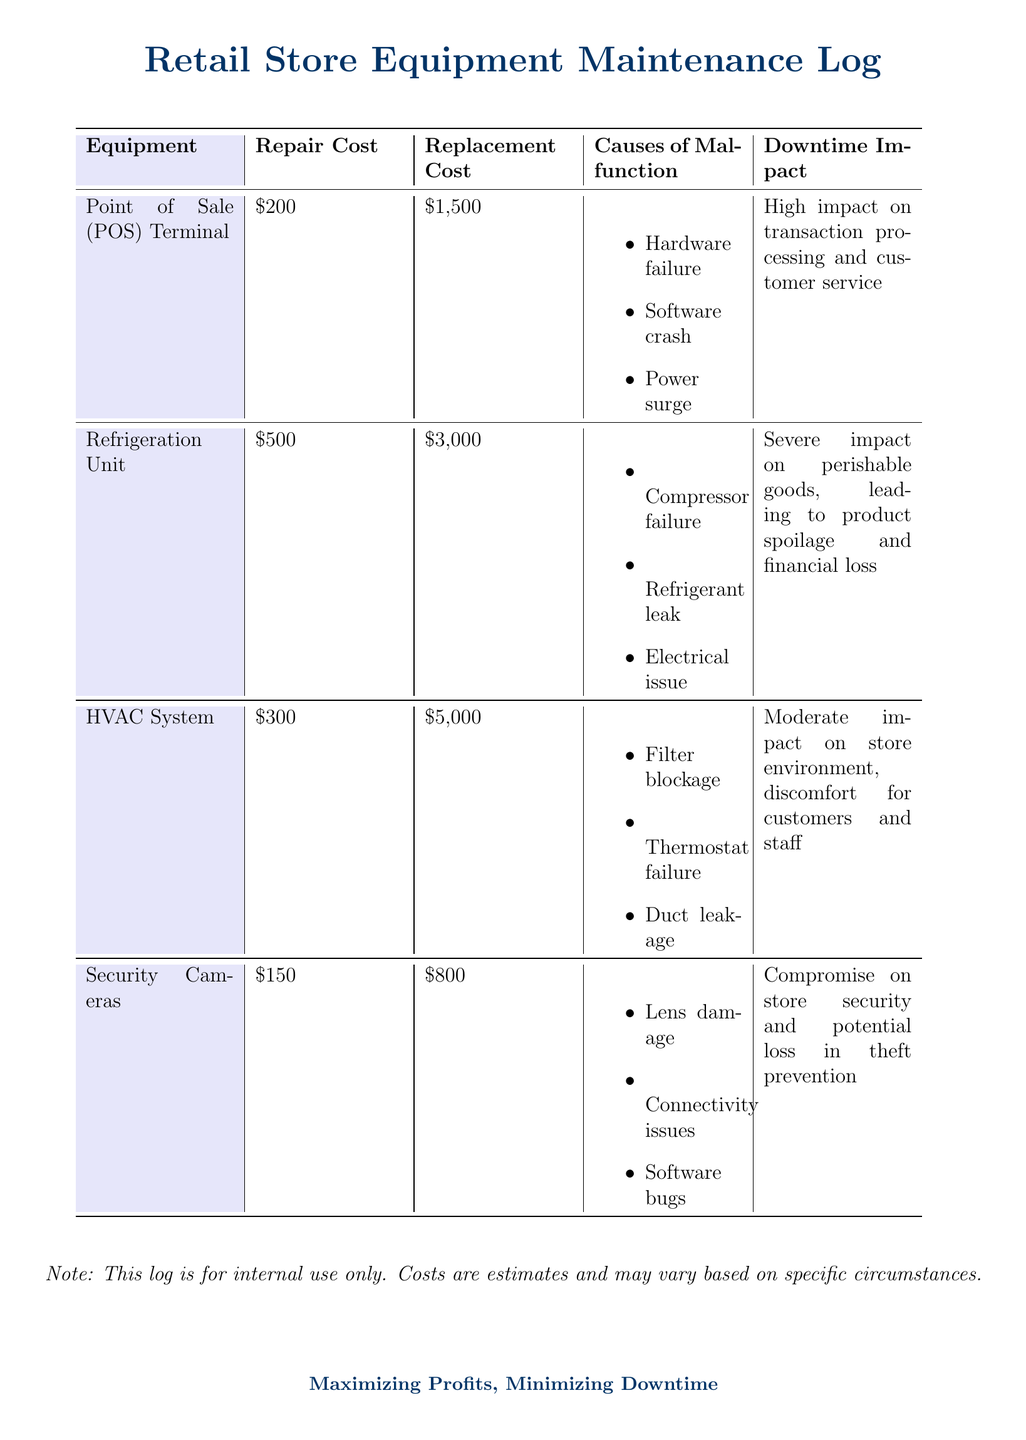What is the repair cost for the POS Terminal? The repair cost for the POS Terminal is listed in the document under the Repair Cost column.
Answer: $200 What causes the HVAC System to malfunction? The causes of malfunction for the HVAC System are outlined in the document under the Causes of Malfunction column.
Answer: Filter blockage, Thermostat failure, Duct leakage What is the replacement cost for the Refrigeration Unit? The replacement cost for the Refrigeration Unit is specified in the document under the Replacement Cost column.
Answer: $3,000 What is the downtime impact of the Security Cameras? The downtime impact of the Security Cameras is described in the document under the Downtime Impact column.
Answer: Compromise on store security and potential loss in theft prevention Which equipment has the highest repair cost? The equipment with the highest repair cost can be determined by comparing the Repair Cost values listed.
Answer: Refrigeration Unit What is the total repair cost for all equipment listed? The total repair cost is the sum of all repair costs listed in the document.
Answer: $1,150 What is the cause of malfunction for the POS Terminal? The causes of malfunction for the POS Terminal are mentioned in the Causes of Malfunction section.
Answer: Hardware failure, Software crash, Power surge Which equipment has a severe impact on product spoilage? The equipment that has a severe impact on product spoilage is indicated in the Downtime Impact section of the document.
Answer: Refrigeration Unit What is the repair cost of the HVAC System? The repair cost for the HVAC System is provided in the Repair Cost column of the document.
Answer: $300 What is the replacement cost of the Security Cameras? The replacement cost for the Security Cameras is detailed in the Replacement Cost column of the document.
Answer: $800 